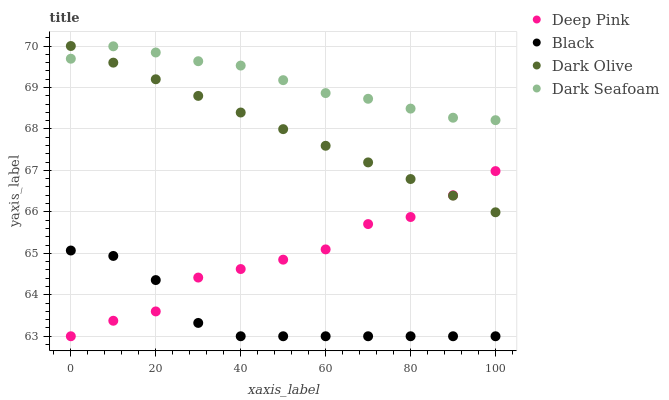Does Black have the minimum area under the curve?
Answer yes or no. Yes. Does Dark Seafoam have the maximum area under the curve?
Answer yes or no. Yes. Does Deep Pink have the minimum area under the curve?
Answer yes or no. No. Does Deep Pink have the maximum area under the curve?
Answer yes or no. No. Is Dark Olive the smoothest?
Answer yes or no. Yes. Is Deep Pink the roughest?
Answer yes or no. Yes. Is Dark Seafoam the smoothest?
Answer yes or no. No. Is Dark Seafoam the roughest?
Answer yes or no. No. Does Deep Pink have the lowest value?
Answer yes or no. Yes. Does Dark Seafoam have the lowest value?
Answer yes or no. No. Does Dark Olive have the highest value?
Answer yes or no. Yes. Does Dark Seafoam have the highest value?
Answer yes or no. No. Is Black less than Dark Seafoam?
Answer yes or no. Yes. Is Dark Seafoam greater than Deep Pink?
Answer yes or no. Yes. Does Deep Pink intersect Dark Olive?
Answer yes or no. Yes. Is Deep Pink less than Dark Olive?
Answer yes or no. No. Is Deep Pink greater than Dark Olive?
Answer yes or no. No. Does Black intersect Dark Seafoam?
Answer yes or no. No. 